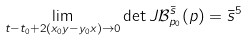Convert formula to latex. <formula><loc_0><loc_0><loc_500><loc_500>\lim _ { t - t _ { 0 } + 2 ( x _ { 0 } y - y _ { 0 } x ) \rightarrow 0 } \det J \mathcal { B } _ { p _ { 0 } } ^ { \bar { s } } ( p ) = \bar { s } ^ { 5 }</formula> 